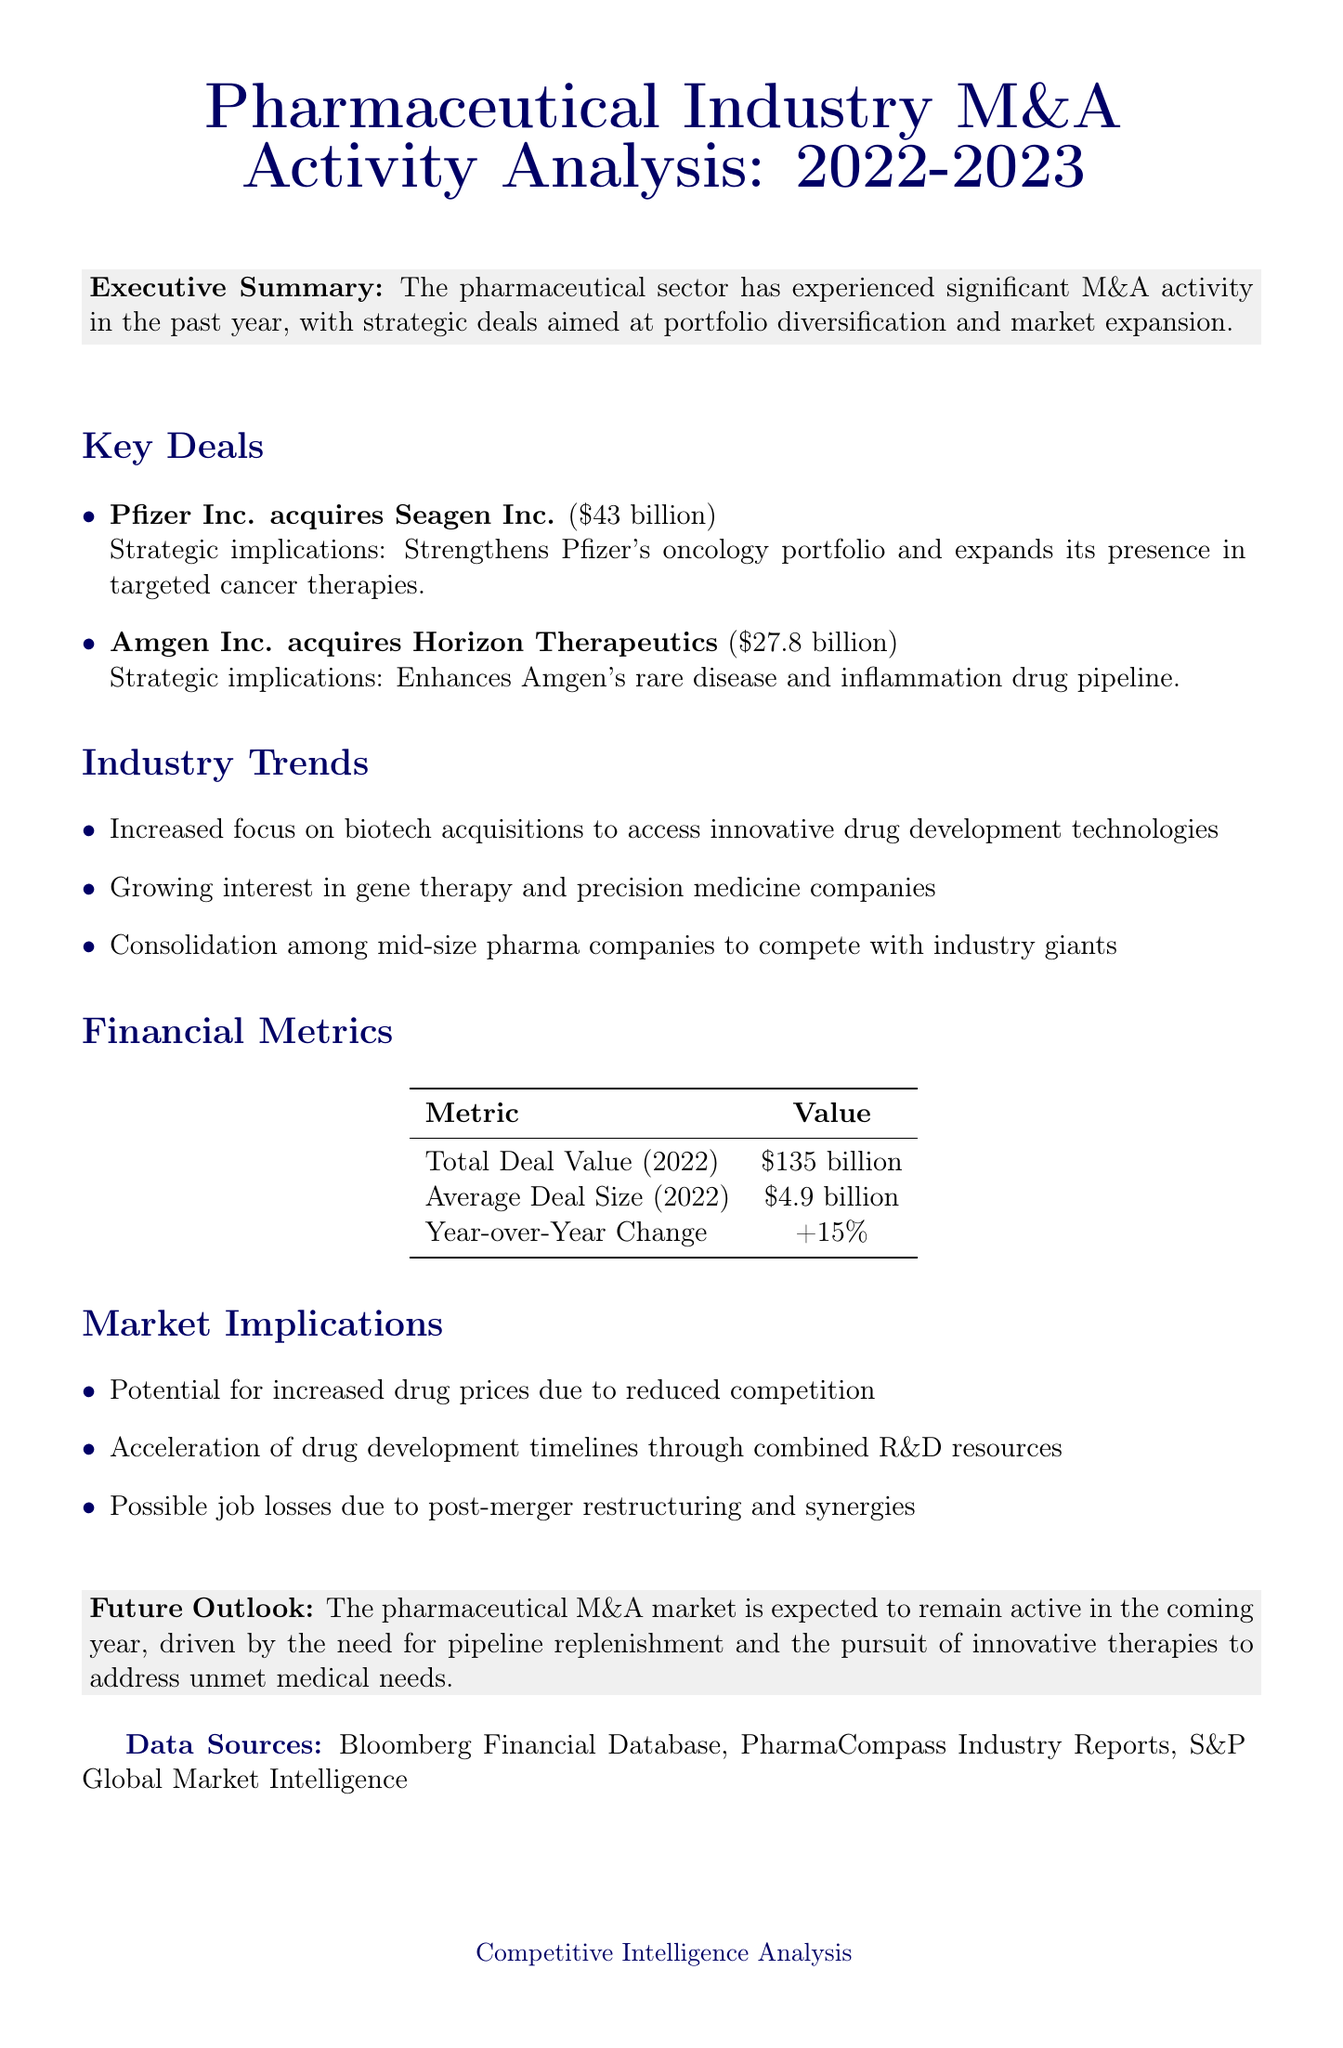What was the deal value of the Pfizer-Seagen acquisition? The document specifies the deal value of Pfizer's acquisition of Seagen as $43 billion.
Answer: $43 billion What strategic implication is associated with the Amgen-Horizon deal? The document states that the strategic implication of this deal is that it enhances Amgen's rare disease and inflammation drug pipeline.
Answer: Enhances Amgen's rare disease and inflammation drug pipeline What is the average deal size in 2022? According to the financial metrics in the document, the average deal size for 2022 is $4.9 billion.
Answer: $4.9 billion Which industry trend highlights the focus on innovative drug development? The document mentions an increased focus on biotech acquisitions to access innovative drug development technologies as a trend.
Answer: Increased focus on biotech acquisitions What is the predicted future outlook for the pharmaceutical M&A market? The future outlook states that the M&A market is expected to remain active, driven by pipeline replenishment and pursuit of innovative therapies.
Answer: Expected to remain active What was the total deal value in 2022? The total deal value listed in the financial metrics section of the document for 2022 is $135 billion.
Answer: $135 billion What are possible job losses attributed to? The document indicates that possible job losses are due to post-merger restructuring and synergies.
Answer: Post-merger restructuring and synergies What data source is mentioned for market intelligence? The document includes S&P Global Market Intelligence as one of the data sources.
Answer: S&P Global Market Intelligence 